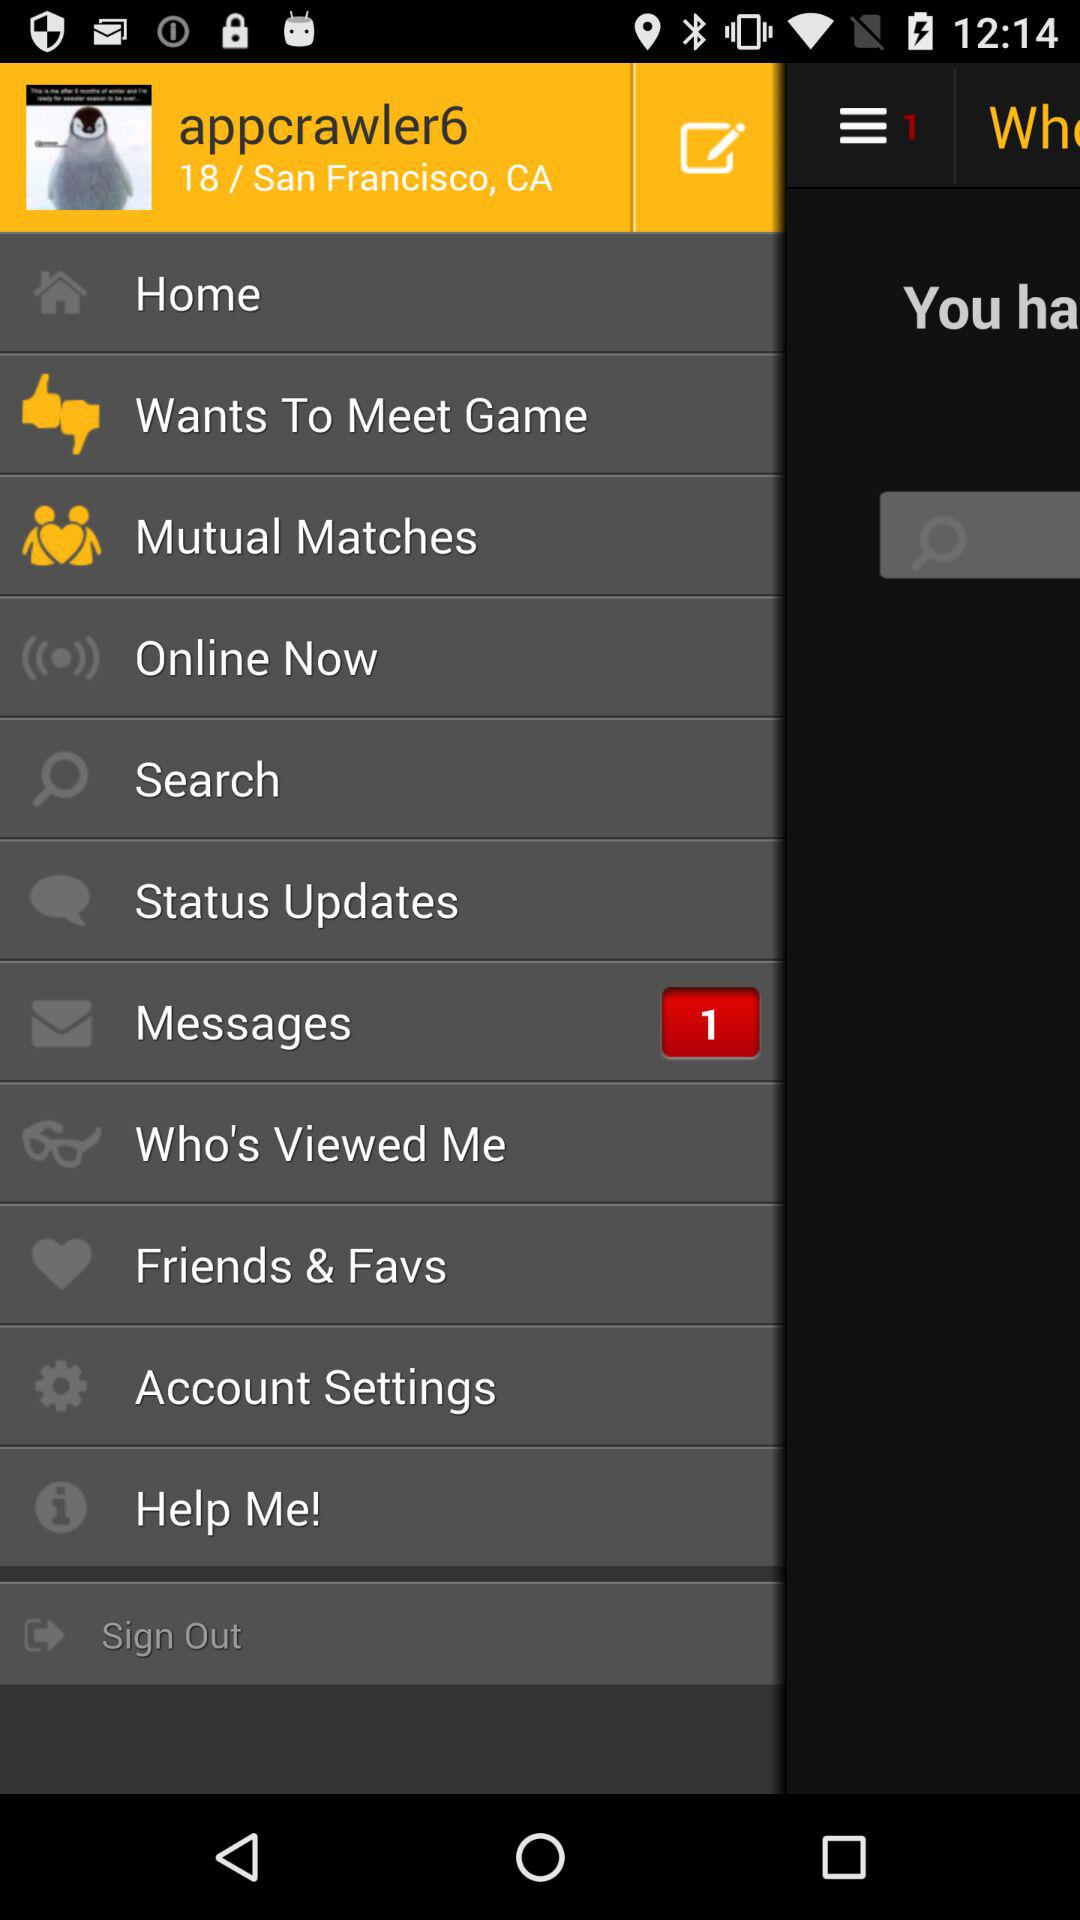How many unread messages are there? There is 1 unread message. 